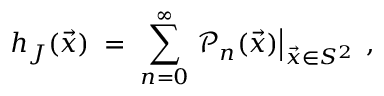Convert formula to latex. <formula><loc_0><loc_0><loc_500><loc_500>h _ { J } ( \vec { x } ) \, = \, \sum _ { n = 0 } ^ { \infty } { \mathcal { P } } _ { n } ( \vec { x } ) \right | _ { \vec { x } \in S ^ { 2 } } \, ,</formula> 